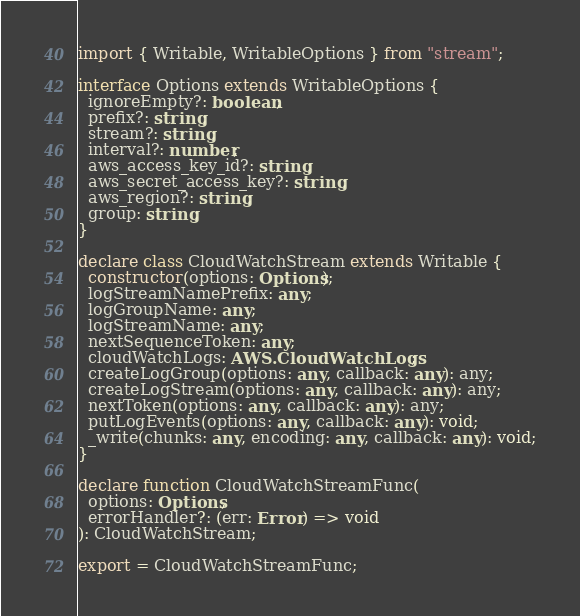Convert code to text. <code><loc_0><loc_0><loc_500><loc_500><_TypeScript_>import { Writable, WritableOptions } from "stream";

interface Options extends WritableOptions {
  ignoreEmpty?: boolean;
  prefix?: string;
  stream?: string;
  interval?: number;
  aws_access_key_id?: string;
  aws_secret_access_key?: string;
  aws_region?: string;
  group: string;
}

declare class CloudWatchStream extends Writable {
  constructor(options: Options);
  logStreamNamePrefix: any;
  logGroupName: any;
  logStreamName: any;
  nextSequenceToken: any;
  cloudWatchLogs: AWS.CloudWatchLogs;
  createLogGroup(options: any, callback: any): any;
  createLogStream(options: any, callback: any): any;
  nextToken(options: any, callback: any): any;
  putLogEvents(options: any, callback: any): void;
  _write(chunks: any, encoding: any, callback: any): void;
}

declare function CloudWatchStreamFunc(
  options: Options,
  errorHandler?: (err: Error) => void
): CloudWatchStream;

export = CloudWatchStreamFunc;
</code> 